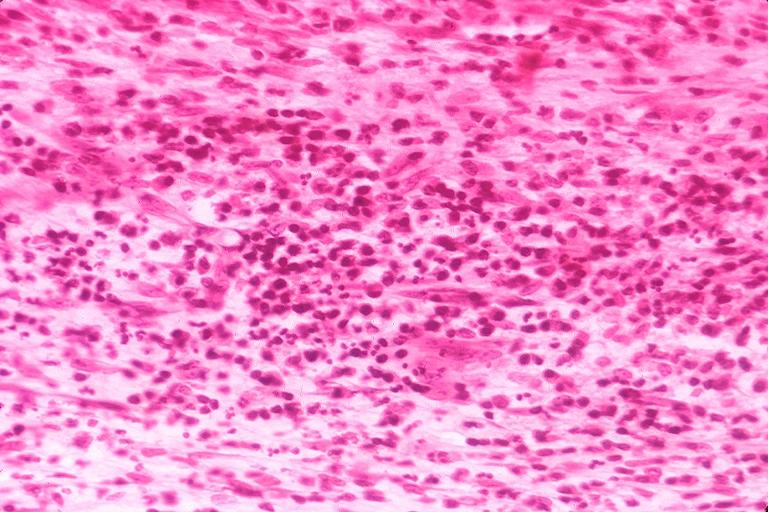s oral present?
Answer the question using a single word or phrase. Yes 